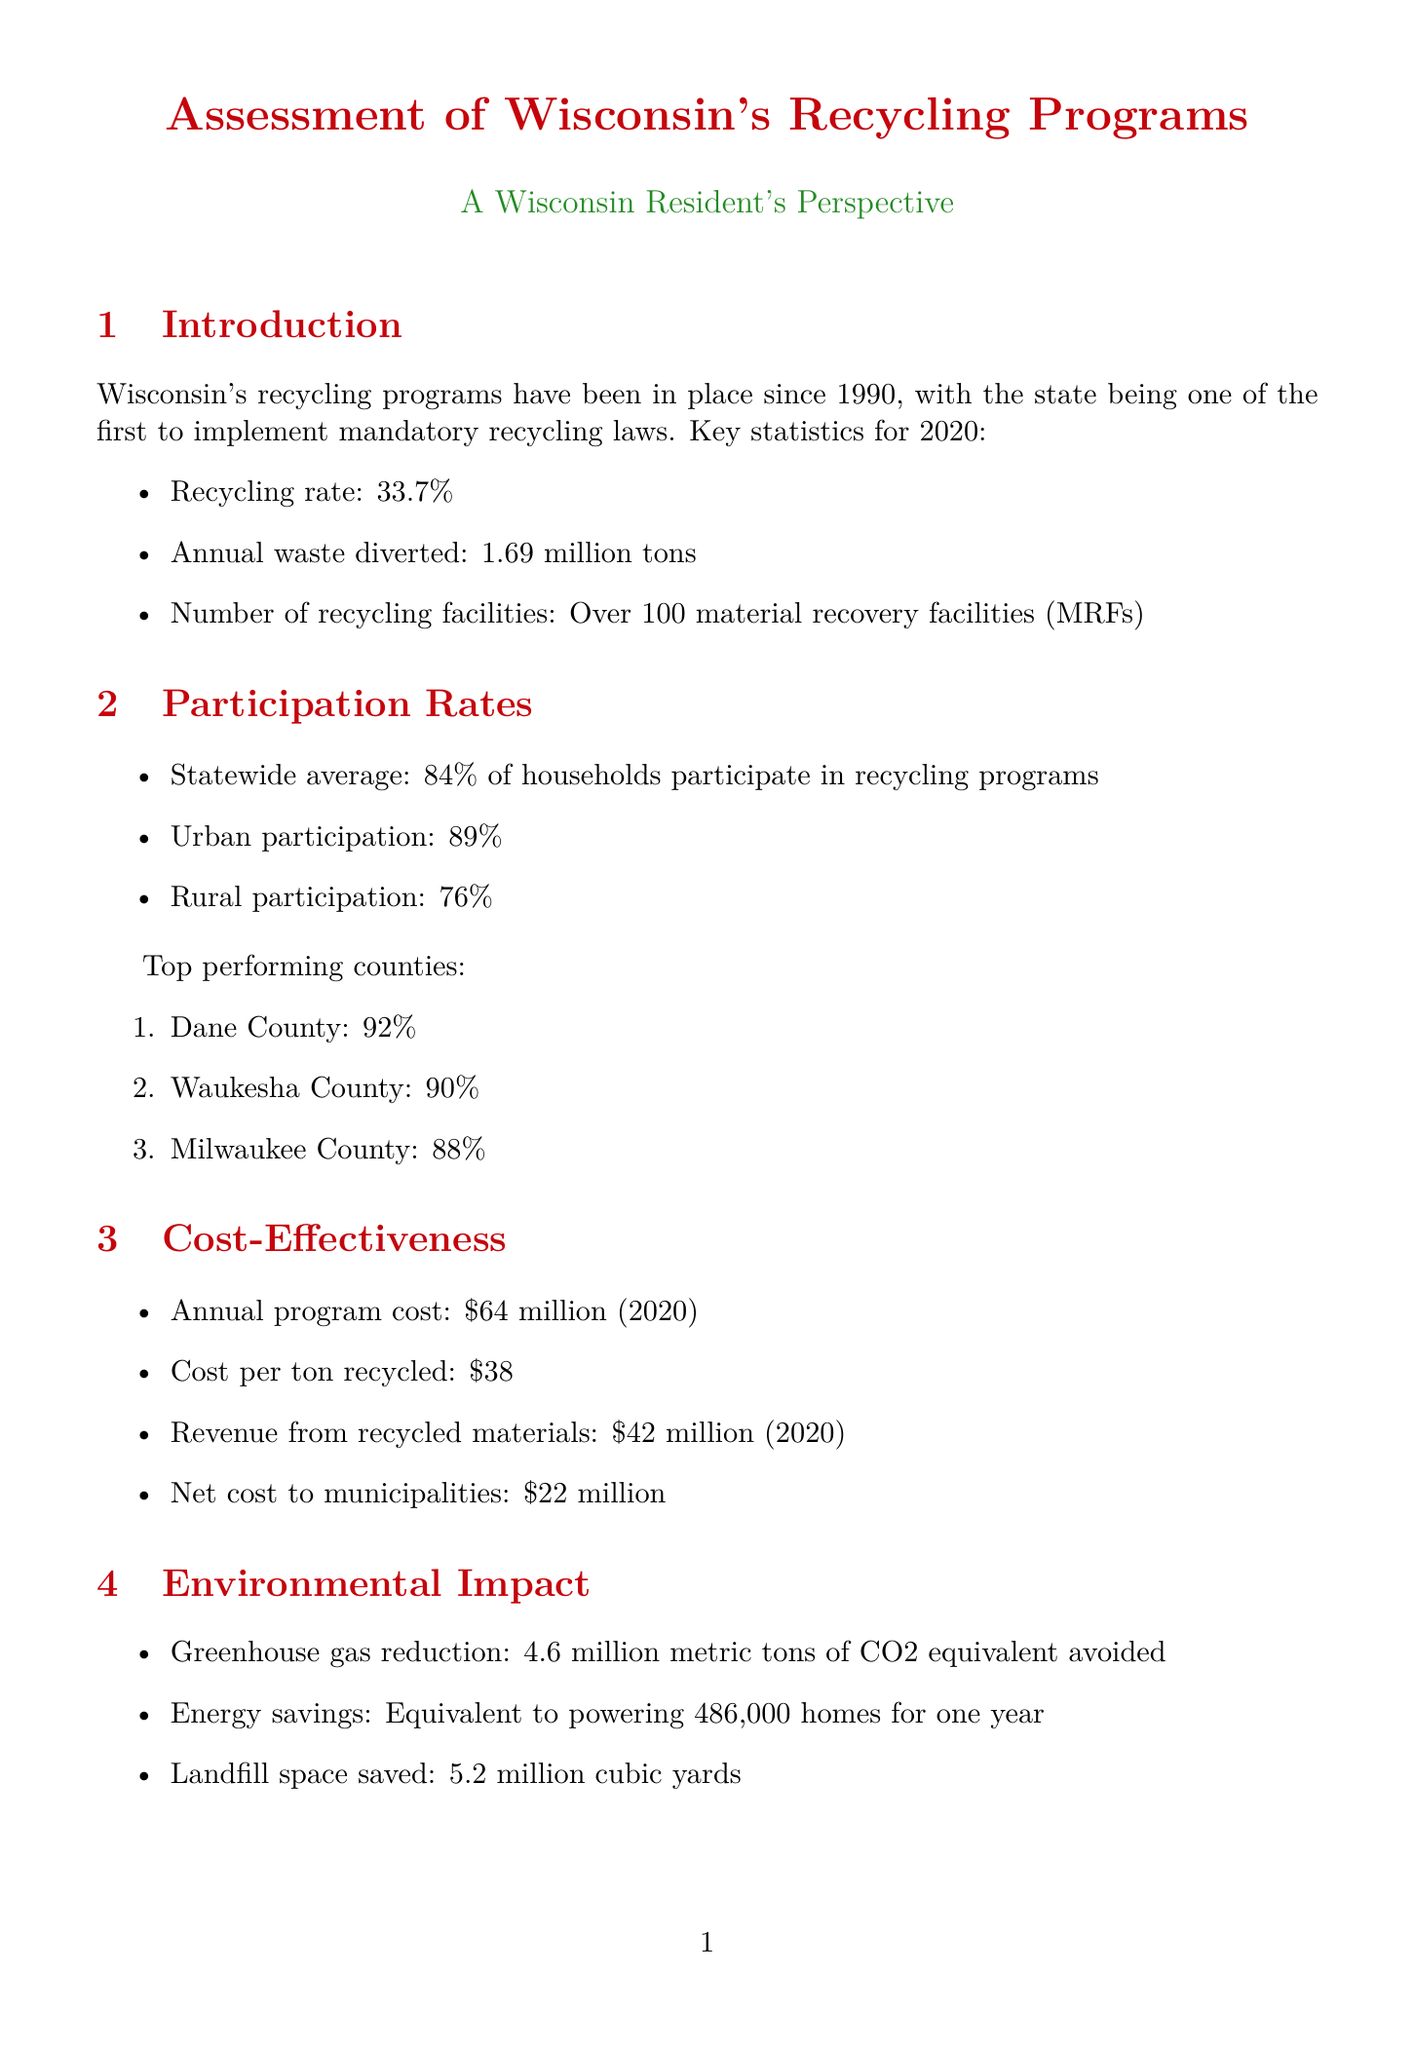What is the recycling rate in 2020? The recycling rate for Wisconsin in 2020 is mentioned as 33.7%.
Answer: 33.7% How many tons of waste were diverted annually? The report states that Wisconsin diverted 1.69 million tons of waste annually.
Answer: 1.69 million tons What is the annual program cost for recycling in 2020? The annual program cost for Wisconsin's recycling is listed as $64 million in 2020.
Answer: $64 million Which county has the highest recycling participation rate? The document lists Dane County as having the highest recycling participation rate at 92%.
Answer: Dane County What is the estimated impact of modernizing MRFs? The estimated impact of modernizing MRFs is a 15% increase in material recovery and $5 million in annual savings.
Answer: 15% increase in material recovery, $5 million annual savings What challenge is related to public awareness? One of the identified challenges in the document is public education and awareness.
Answer: Public education and awareness What future policy consideration is mentioned? Extended Producer Responsibility legislation is mentioned as a future policy consideration.
Answer: Extended Producer Responsibility legislation How much greenhouse gas reduction is attributed to recycling? The report indicates that 4.6 million metric tons of CO2 equivalent have been avoided through recycling efforts.
Answer: 4.6 million metric tons What is one emerging technology in waste management? The document notes that artificial intelligence in waste sorting is an emerging technology in waste management.
Answer: Artificial Intelligence in waste sorting 